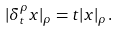Convert formula to latex. <formula><loc_0><loc_0><loc_500><loc_500>| \delta _ { t } ^ { \rho } x | _ { \rho } = t | x | _ { \rho } .</formula> 